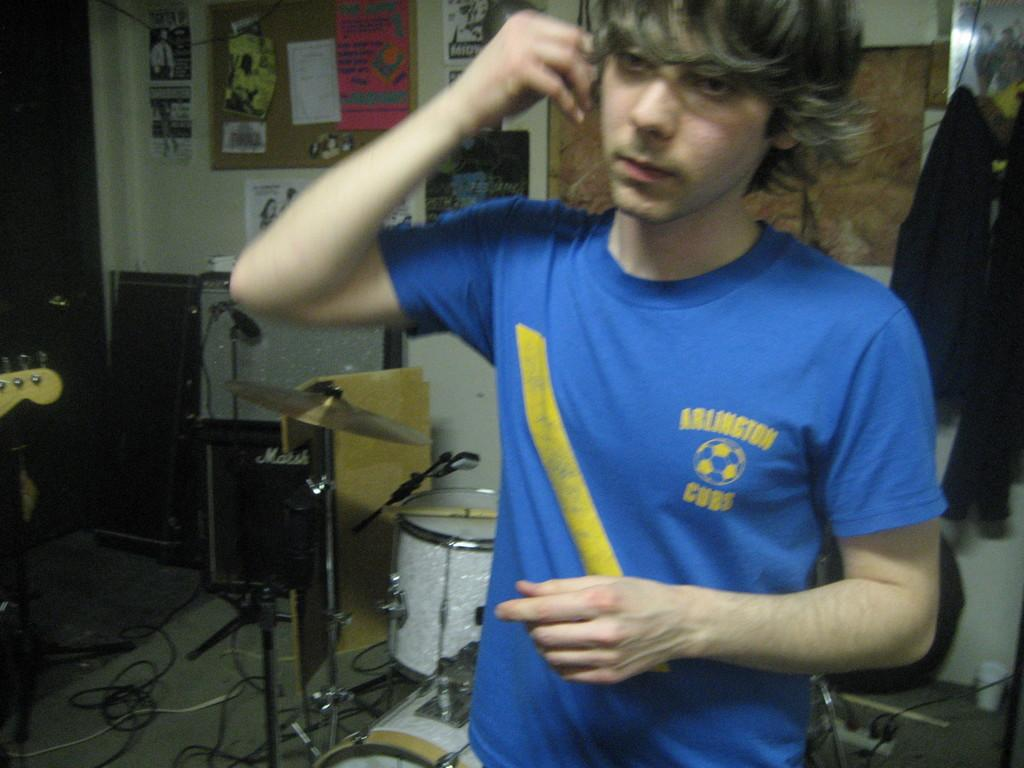Provide a one-sentence caption for the provided image. A boy by a drum set is holding an earbud up to his ear and wearing a blue Arlington Cubs shirt. 